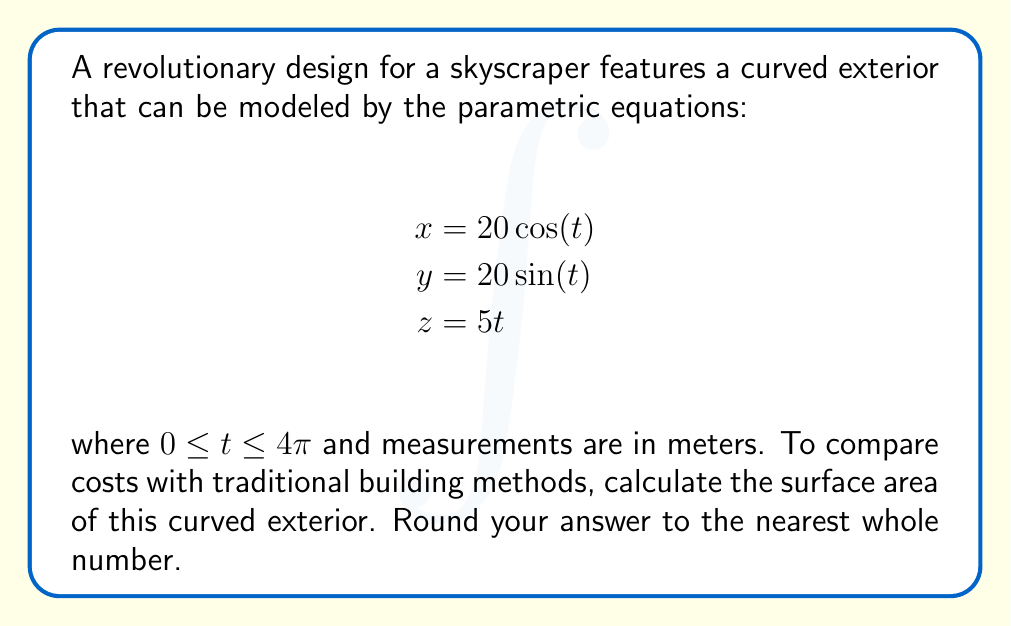Solve this math problem. To calculate the surface area of this parametric surface, we'll use the surface area formula for parametric equations:

$$A = \int_{a}^{b} \int_{c}^{d} \sqrt{(y_uz_v - y_vz_u)^2 + (z_ux_v - z_vx_u)^2 + (x_uy_v - x_vy_u)^2} \,du\,dv$$

Where subscripts denote partial derivatives.

Step 1: Calculate partial derivatives
$x_t = -20\sin(t)$
$y_t = 20\cos(t)$
$z_t = 5$

Step 2: Substitute into the formula
$$(y_tz_t - y_tz_t)^2 + (z_tx_t - z_tx_t)^2 + (x_ty_t - x_ty_t)^2$$
$$= (20\cos(t) \cdot 5 - 20\cos(t) \cdot 5)^2 + (5 \cdot (-20\sin(t)) - 5 \cdot (-20\sin(t)))^2 + ((-20\sin(t)) \cdot 20\cos(t) - (-20\sin(t)) \cdot 20\cos(t))^2$$
$$= 0^2 + 0^2 + 0^2 = 0$$

Step 3: Simplify the integrand
$\sqrt{(20\cos(t) \cdot 5)^2 + (5 \cdot (-20\sin(t)))^2 + ((-20\sin(t)) \cdot 20\cos(t))^2}$
$= \sqrt{10000\cos^2(t) + 10000\sin^2(t) + 160000\sin^2(t)\cos^2(t)}$
$= \sqrt{10000(\cos^2(t) + \sin^2(t)) + 160000\sin^2(t)\cos^2(t)}$
$= \sqrt{10000 + 160000\sin^2(t)\cos^2(t)}$
$= \sqrt{10000(1 + 16\sin^2(t)\cos^2(t))}$
$= 100\sqrt{1 + 16\sin^2(t)\cos^2(t)}$

Step 4: Set up and evaluate the integral
$$A = \int_{0}^{4\pi} 100\sqrt{1 + 16\sin^2(t)\cos^2(t)} \,dt$$

This integral doesn't have an elementary antiderivative, so we'll use numerical integration.

Using a numerical integration method (e.g., Simpson's rule or a computer algebra system), we get:

$$A \approx 2513.27$$

Step 5: Round to the nearest whole number
$$A \approx 2513 \text{ m}^2$$
Answer: 2513 m² 